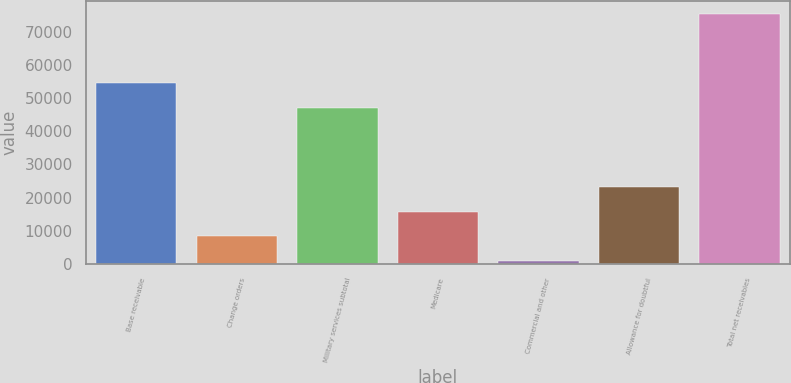Convert chart to OTSL. <chart><loc_0><loc_0><loc_500><loc_500><bar_chart><fcel>Base receivable<fcel>Change orders<fcel>Military services subtotal<fcel>Medicare<fcel>Commercial and other<fcel>Allowance for doubtful<fcel>Total net receivables<nl><fcel>54476.1<fcel>8277.1<fcel>47018<fcel>15735.2<fcel>819<fcel>23193.3<fcel>75400<nl></chart> 